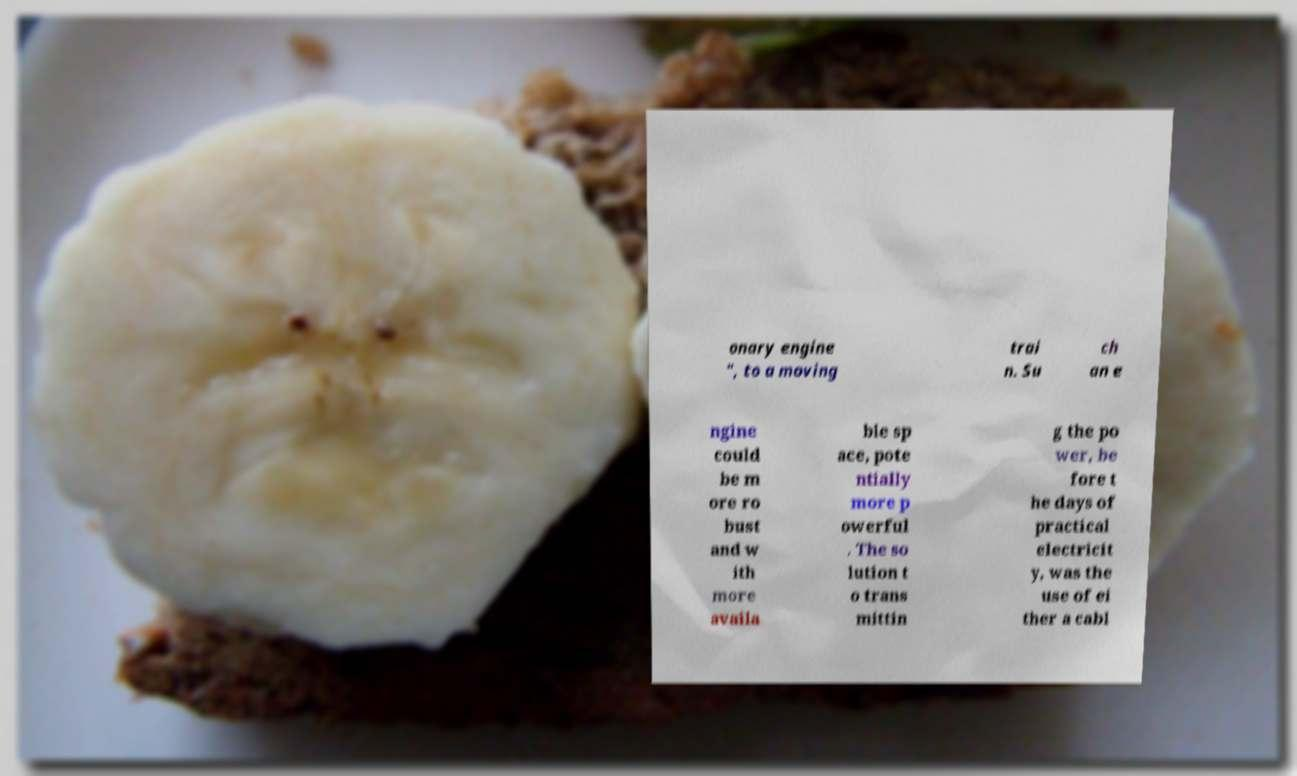Please read and relay the text visible in this image. What does it say? onary engine ", to a moving trai n. Su ch an e ngine could be m ore ro bust and w ith more availa ble sp ace, pote ntially more p owerful . The so lution t o trans mittin g the po wer, be fore t he days of practical electricit y, was the use of ei ther a cabl 